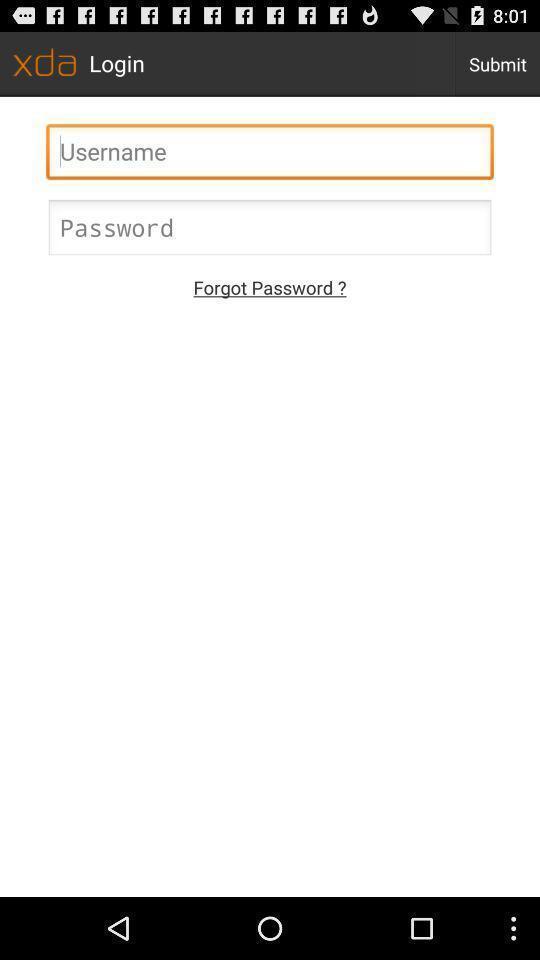What is the overall content of this screenshot? Page displaying the login. 